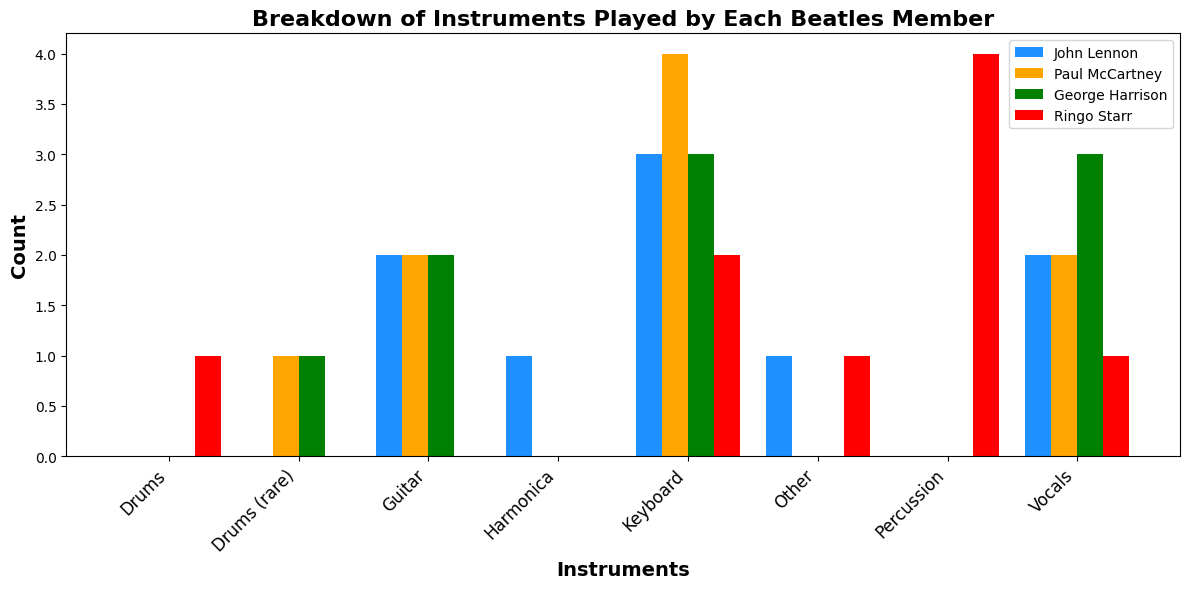Which Beatles member played the guitar the most? By examining the height of the bars representing guitar playing for each Beatles member, the tallest bar indicates the member who played it the most. John Lennon's bar is the tallest for the guitar category.
Answer: John Lennon Who played the keyboard: piano more, Paul McCartney or George Harrison? Compare the heights of the bars for the keyboard: piano category between Paul McCartney and George Harrison. Paul's bar is taller than George's.
Answer: Paul McCartney Which instrument was played equally by John Lennon and Ringo Starr? Looking at the bars for each instrument category, note the instances where the bars for John Lennon and Ringo Starr are of the same height. Both played keyboard: organ equally.
Answer: Keyboard: Organ How many unique instruments did George Harrison play? Count the number of different instrument categories that have a bar representing George Harrison. George has bars for seven categories.
Answer: Seven (7) What is the total count of percussion instruments played by Ringo Starr? Sum the heights of the bars representing different percussion instruments (percussion, tambourine, maracas, bongos) for Ringo Starr. The counts are 1 (percussion) + 1 (maracas) + 1 (bongos) = 3.
Answer: Three (3) What is the most frequently played instrument by any Beatles member? Identify the highest bar overall, regardless of the member, which indicates the most commonly played instrument. The guitar category covered by various members is the highest cumulatively, especially John Lennon's guitar: rhythm.
Answer: Guitar Which member contributed least to vocals: harmony? Compare the heights of the vocals: harmony bars among all members. Ringo Starr has no bar for vocals: harmony, showing he contributed the least.
Answer: Ringo Starr What is the difference in the number of times Paul McCartney and George Harrison played the mellotron? Compare the height of the mellotron bars for both Paul McCartney and George Harrison and subtract the smaller from the larger. Both have the same height (one count each). The difference is 0.
Answer: Zero (0) What color represents the bar for instruments played by George Harrison? Identify the color assigned to George Harrison in the legend. The bars for George Harrison are colored green.
Answer: Green How many total bars represent instruments played by John Lennon? Count all the individual bars representing different instruments played by John Lennon. There are six bars.
Answer: Six (6) 